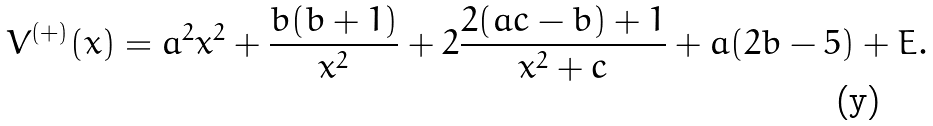<formula> <loc_0><loc_0><loc_500><loc_500>V ^ { ( + ) } ( x ) = a ^ { 2 } x ^ { 2 } + \frac { b ( b + 1 ) } { x ^ { 2 } } + 2 \frac { 2 ( a c - b ) + 1 } { x ^ { 2 } + c } + a ( 2 b - 5 ) + E .</formula> 